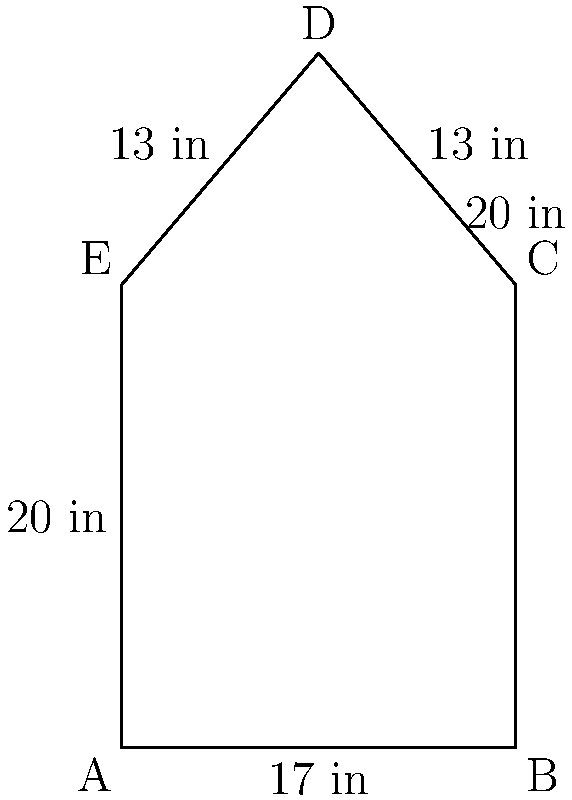As a minor league pitcher, you're analyzing the strike zone represented by the pentagon ABCDE. Given that AB = 17 inches, BC = 20 inches, and the distance from point D to line AC is 10 inches, calculate the area of the strike zone in square inches. Let's approach this step-by-step:

1) The strike zone can be divided into a rectangle (ABCE) and a triangle (CDE).

2) For the rectangle ABCE:
   Area of rectangle = AB × AE = 17 × 20 = 340 sq inches

3) For the triangle CDE:
   We need to find its base (CE) and height (perpendicular from D to AC).
   
   The height is given as 10 inches.
   
   To find CE, we can use the Pythagorean theorem:
   $CE^2 = CD^2 - DE^2 = 13^2 - 10^2 = 169 - 100 = 69$
   $CE = \sqrt{69} \approx 8.3$ inches

4) Area of triangle CDE:
   $A_{triangle} = \frac{1}{2} × base × height = \frac{1}{2} × 8.3 × 10 = 41.5$ sq inches

5) Total area of the strike zone:
   $A_{total} = A_{rectangle} + A_{triangle} = 340 + 41.5 = 381.5$ sq inches

Therefore, the area of the strike zone is approximately 381.5 square inches.
Answer: 381.5 sq inches 